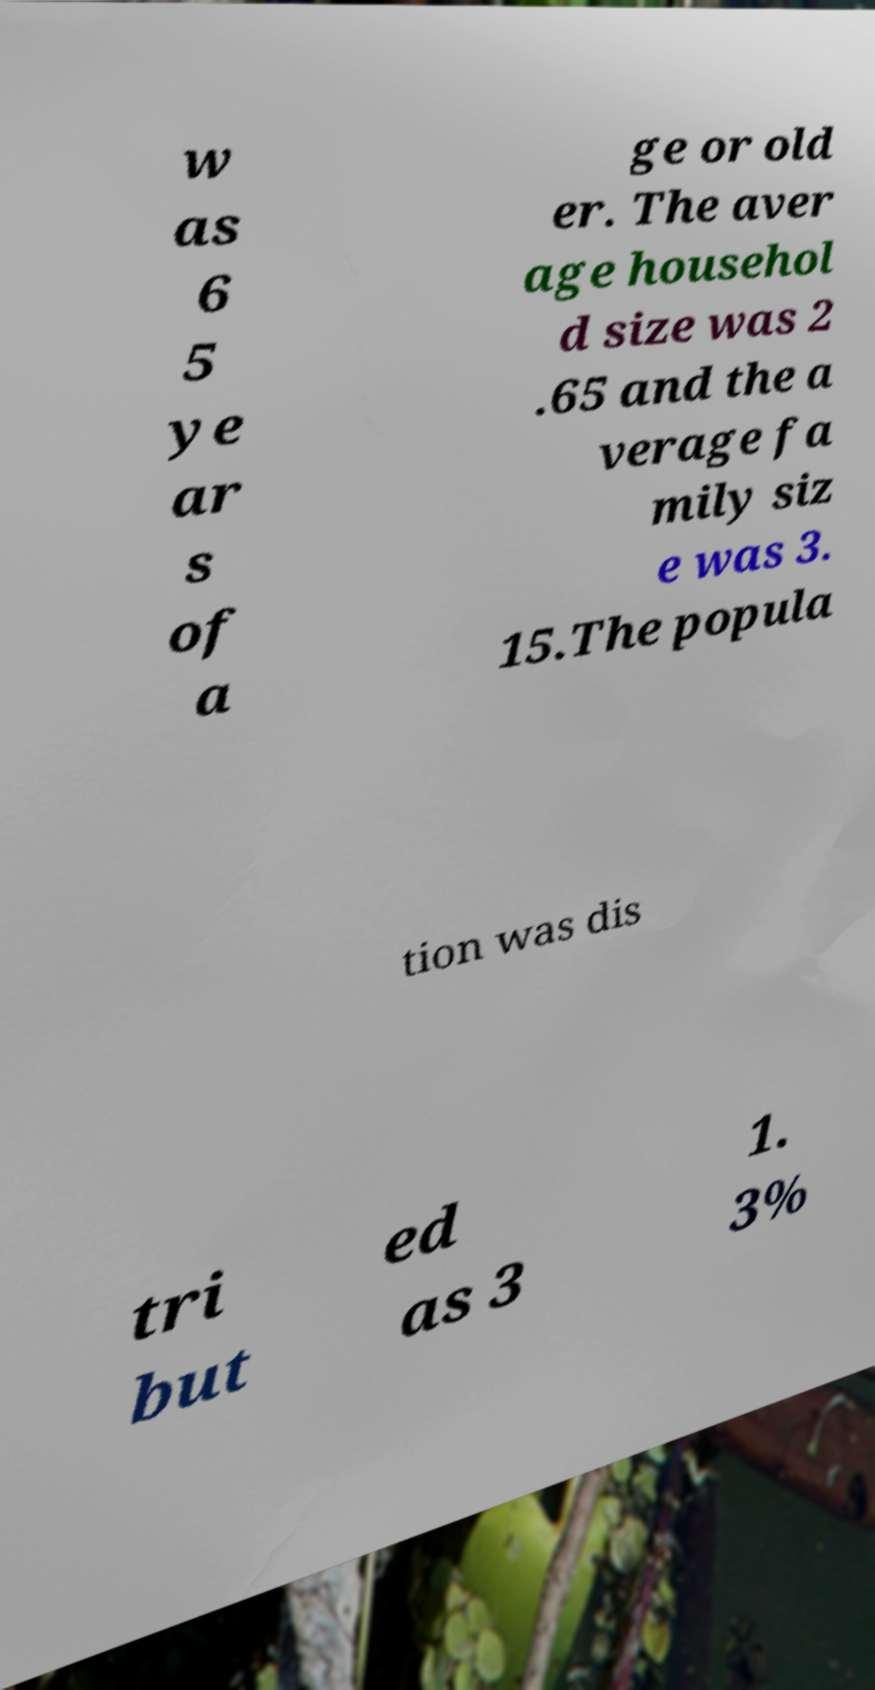What messages or text are displayed in this image? I need them in a readable, typed format. w as 6 5 ye ar s of a ge or old er. The aver age househol d size was 2 .65 and the a verage fa mily siz e was 3. 15.The popula tion was dis tri but ed as 3 1. 3% 